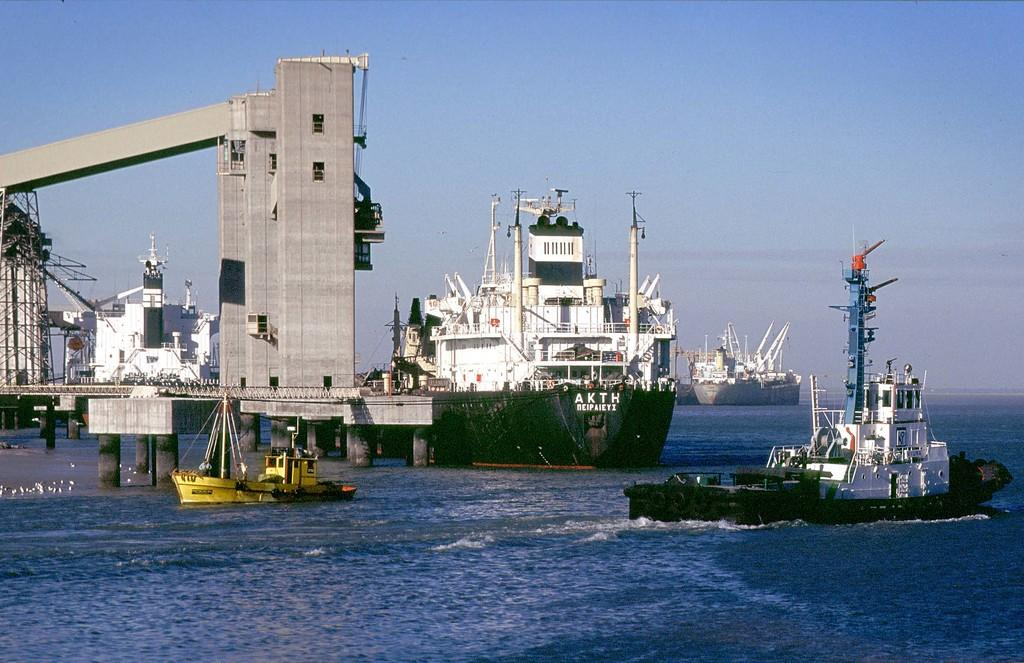<image>
Relay a brief, clear account of the picture shown. A boat with the letters AKTH is in the water next to a platform. 